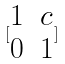<formula> <loc_0><loc_0><loc_500><loc_500>[ \begin{matrix} 1 & c \\ 0 & 1 \end{matrix} ]</formula> 